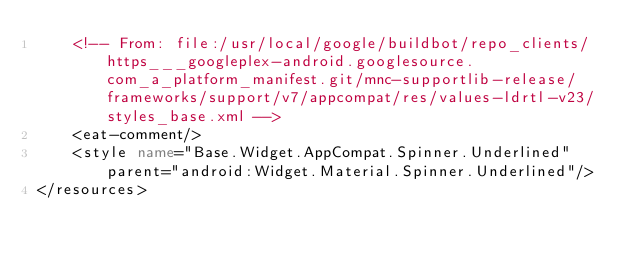Convert code to text. <code><loc_0><loc_0><loc_500><loc_500><_XML_>    <!-- From: file:/usr/local/google/buildbot/repo_clients/https___googleplex-android.googlesource.com_a_platform_manifest.git/mnc-supportlib-release/frameworks/support/v7/appcompat/res/values-ldrtl-v23/styles_base.xml -->
    <eat-comment/>
    <style name="Base.Widget.AppCompat.Spinner.Underlined" parent="android:Widget.Material.Spinner.Underlined"/>
</resources></code> 